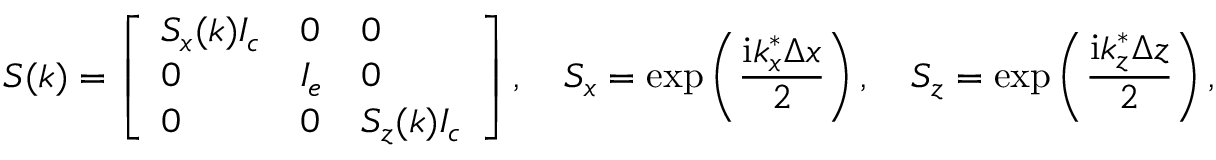Convert formula to latex. <formula><loc_0><loc_0><loc_500><loc_500>S ( k ) = \left [ \begin{array} { l l l } { S _ { x } ( k ) I _ { c } } & { 0 } & { 0 } \\ { 0 } & { I _ { e } } & { 0 } \\ { 0 } & { 0 } & { S _ { z } ( k ) I _ { c } } \end{array} \right ] , \quad S _ { x } = e x p \left ( \frac { i k _ { x } ^ { * } \Delta x } { 2 } \right ) , \quad S _ { z } = e x p \left ( \frac { i k _ { z } ^ { * } \Delta z } { 2 } \right ) ,</formula> 